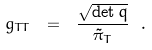Convert formula to latex. <formula><loc_0><loc_0><loc_500><loc_500>g _ { T T } \ = \ \frac { \sqrt { \det q } } { \tilde { \pi } _ { T } } \ .</formula> 